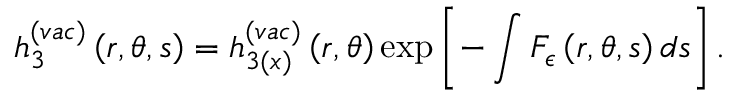<formula> <loc_0><loc_0><loc_500><loc_500>h _ { 3 } ^ { ( v a c ) } \left ( r , \theta , s \right ) = h _ { 3 ( x ) } ^ { ( v a c ) } \left ( r , \theta \right ) \exp \left [ - \int F _ { \epsilon } \left ( r , \theta , s \right ) d s \right ] .</formula> 